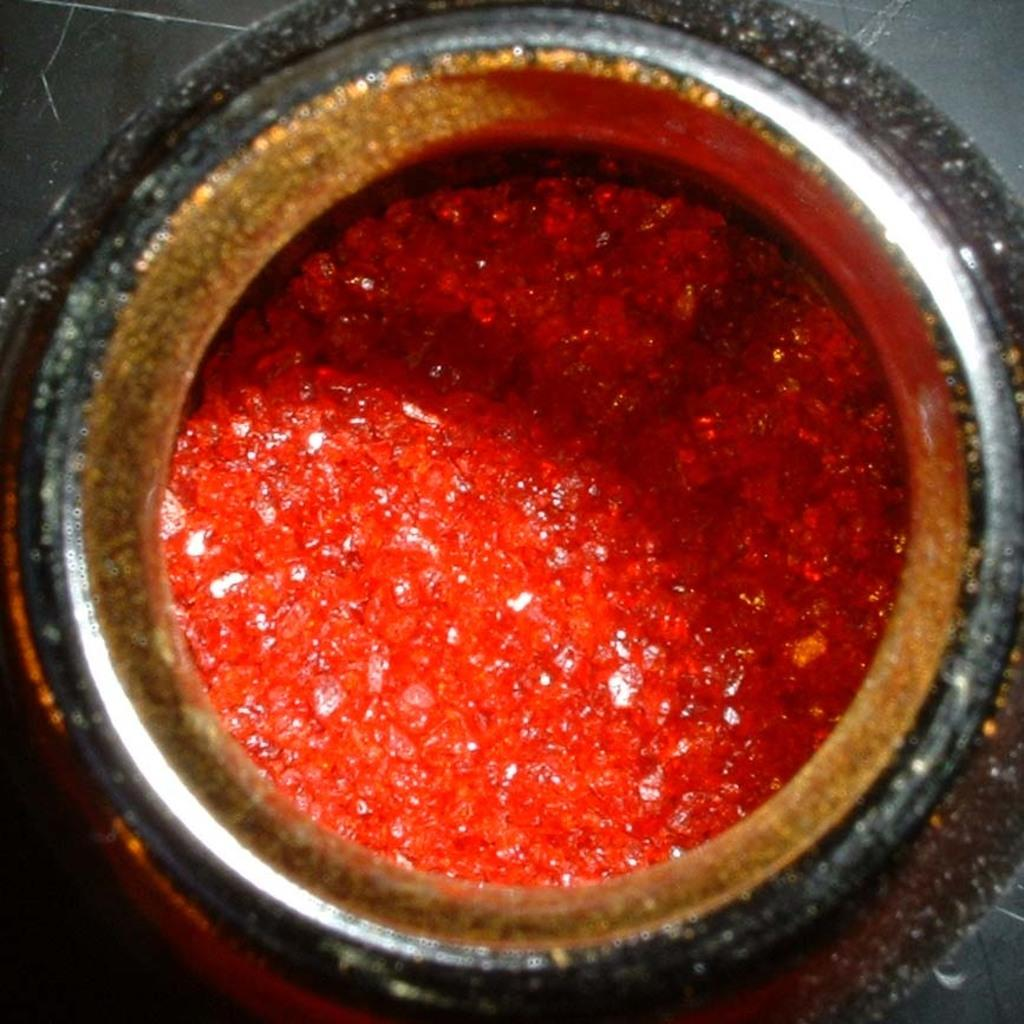What object is located on the floor in the image? There is a jar on the floor in the image. What is inside the jar? There is a red color mixture in the jar. Can you tell me how many people are drinking the red mixture from the jar in the image? There is no indication of people drinking from the jar in the image. 